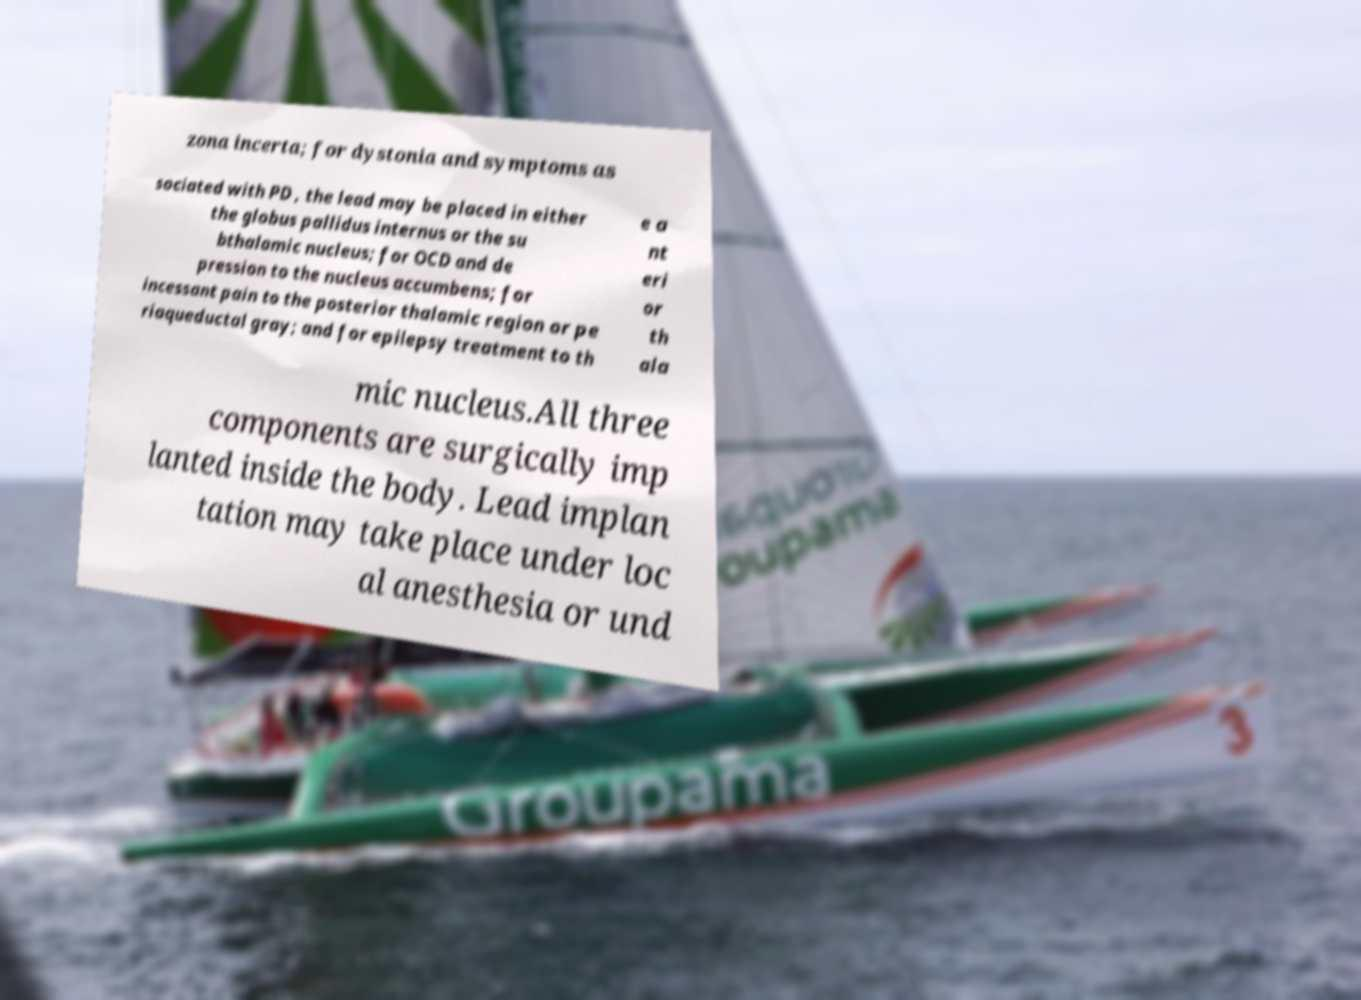Please identify and transcribe the text found in this image. zona incerta; for dystonia and symptoms as sociated with PD , the lead may be placed in either the globus pallidus internus or the su bthalamic nucleus; for OCD and de pression to the nucleus accumbens; for incessant pain to the posterior thalamic region or pe riaqueductal gray; and for epilepsy treatment to th e a nt eri or th ala mic nucleus.All three components are surgically imp lanted inside the body. Lead implan tation may take place under loc al anesthesia or und 